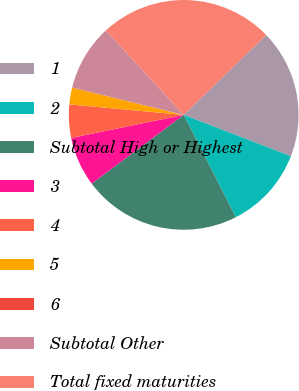Convert chart. <chart><loc_0><loc_0><loc_500><loc_500><pie_chart><fcel>1<fcel>2<fcel>Subtotal High or Highest<fcel>3<fcel>4<fcel>5<fcel>6<fcel>Subtotal Other<fcel>Total fixed maturities<nl><fcel>18.1%<fcel>11.64%<fcel>22.28%<fcel>7.0%<fcel>4.67%<fcel>2.35%<fcel>0.03%<fcel>9.32%<fcel>24.6%<nl></chart> 